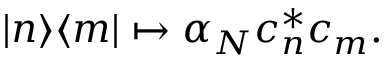Convert formula to latex. <formula><loc_0><loc_0><loc_500><loc_500>| n \rangle \langle m | \mapsto \alpha _ { N } c _ { n } ^ { * } c _ { m } .</formula> 